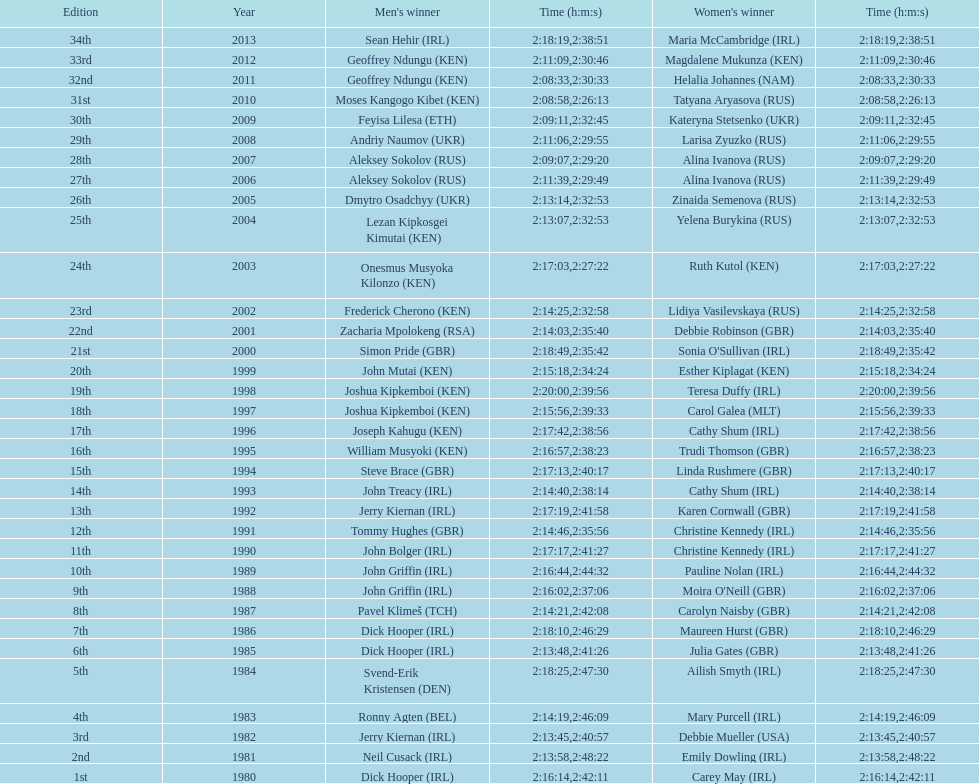In which country are both men and women featured at the highest position on the list? Ireland. 